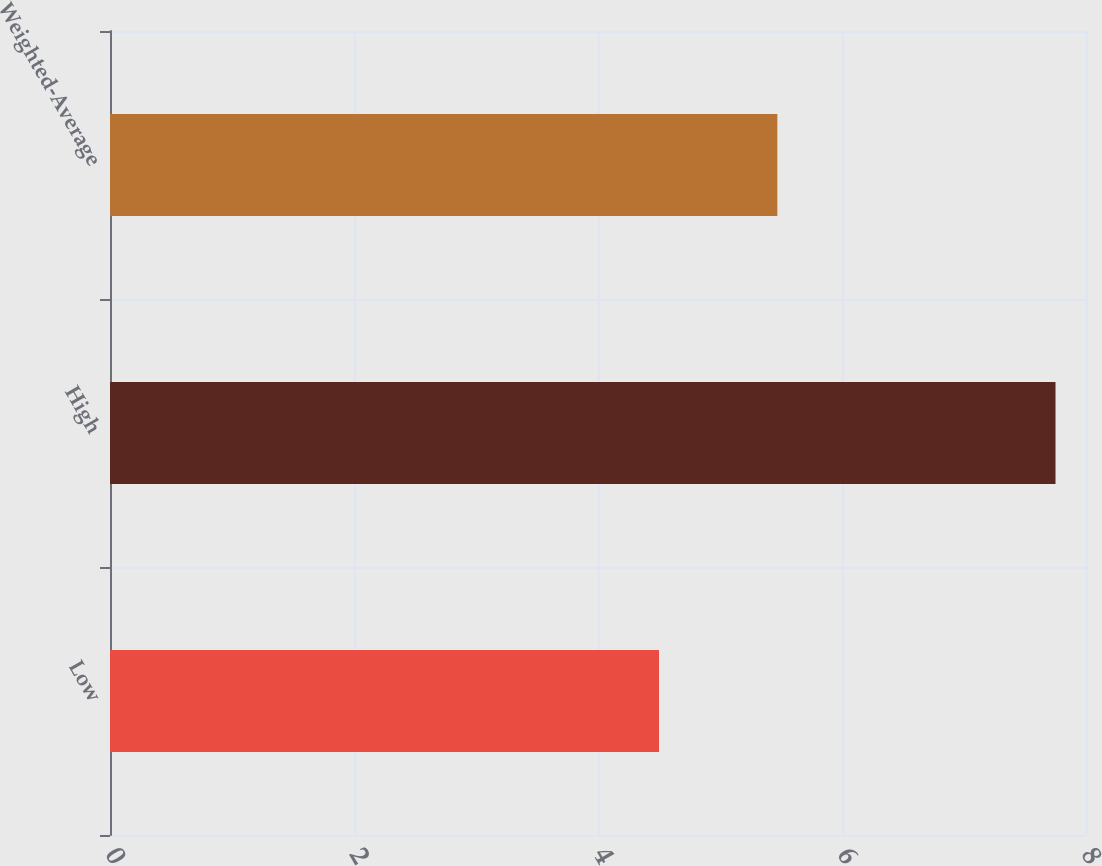<chart> <loc_0><loc_0><loc_500><loc_500><bar_chart><fcel>Low<fcel>High<fcel>Weighted-Average<nl><fcel>4.5<fcel>7.75<fcel>5.47<nl></chart> 